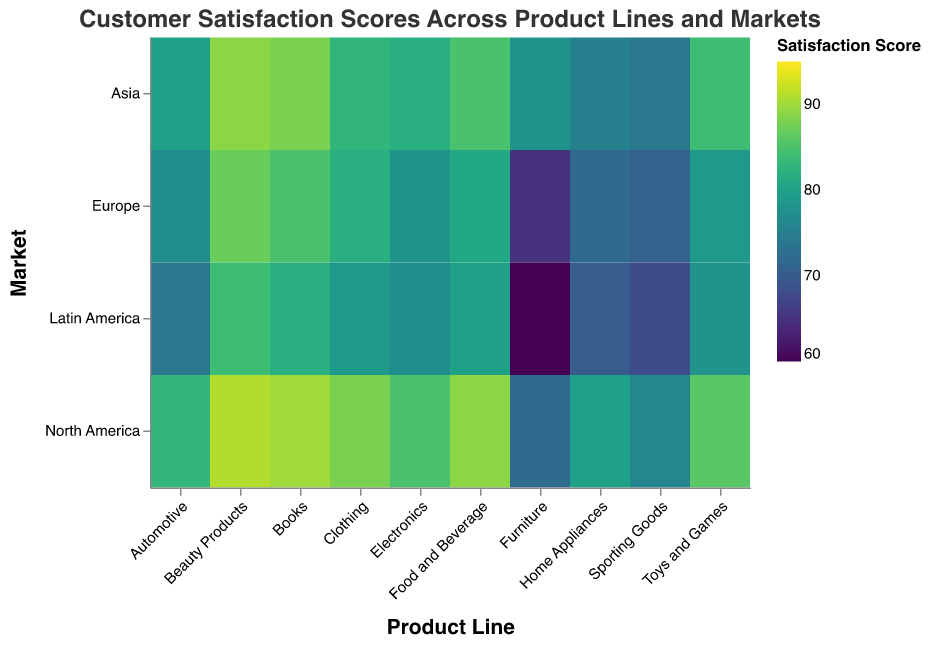What is the title of the heatmap? The title is displayed at the top of the heatmap, indicating the overall topic it covers. It helps in identifying the main focus of the visualization.
Answer: Customer Satisfaction Scores Across Product Lines and Markets Which product line has the highest customer satisfaction in North America? By observing the heatmap, you can compare the color intensity or score labels across the 'North America' column for each product line. The highest value corresponds to the product line being queried.
Answer: Beauty Products Which geographical market has the lowest customer satisfaction score for Furniture? Look at the Furniture row and find the market column with the lowest score. The lightest color or the smallest value indicates the lowest satisfaction score.
Answer: Latin America What is the average customer satisfaction score for Sporting Goods across all markets? Sum the satisfaction scores for Sporting Goods in each of the four markets and then divide by the number of markets (4). Average = (76 + 71 + 74 + 68) / 4 = 289 / 4 = 72.25.
Answer: 72.25 How many product lines have a customer satisfaction score of 85 or above in Europe? Count the number of cells in the Europe column with a value of 85 or more. The specific product lines that meet this condition are noted.
Answer: 4 Which market has the most uniform customer satisfaction scores across different product lines? Observe the variation in colors within each market column. The market with the least variation in color intensity has the most uniform scores.
Answer: North America What is the difference in customer satisfaction for Beauty Products between Europe and Latin America? Subtract the satisfaction score for Beauty Products in Latin America from the one in Europe. Difference = 87 - 84 = 3.
Answer: 3 Compare the customer satisfaction scores of Automotive and Toys and Games in Asia. Which one is higher? Look at the scores in the Asia column for both Automotive and Toys and Games, then determine which score is higher.
Answer: Toys and Games Explain why comparing customer satisfaction across product lines might be helpful for business strategy. Understanding customer satisfaction levels helps identify strengths and weaknesses across various product lines and markets. This insight can guide product improvements, marketing strategies, and resource allocation to meet customer needs more effectively.
Answer: Identifies strengths and weaknesses, guides strategy If we consider a score of 80 as the threshold for high customer satisfaction, which markets for Automotive exceed this threshold? Check the satisfaction scores for Automotive in each market and list those with scores above 80. The markets with a score above 80 are North America and Asia.
Answer: North America, Asia 